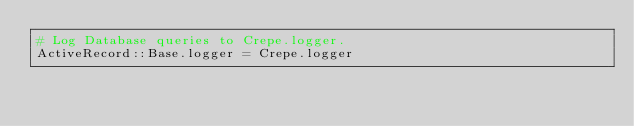<code> <loc_0><loc_0><loc_500><loc_500><_Ruby_># Log Database queries to Crepe.logger.
ActiveRecord::Base.logger = Crepe.logger
</code> 